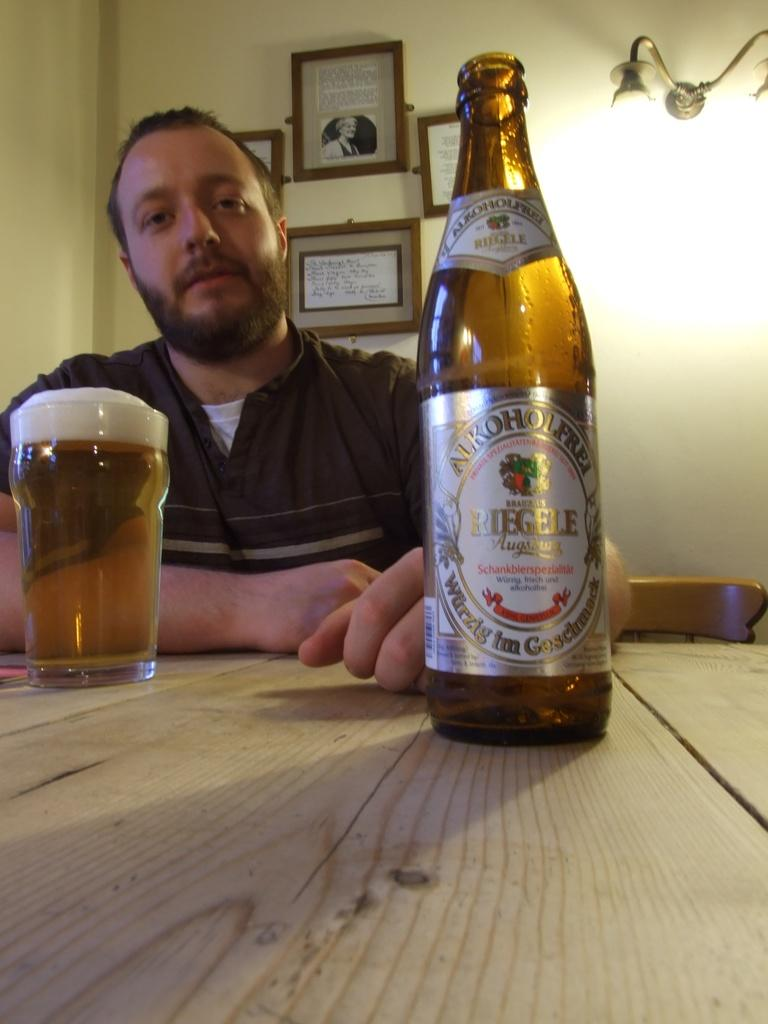<image>
Relay a brief, clear account of the picture shown. A bottle of beer with Riegel on the label. 